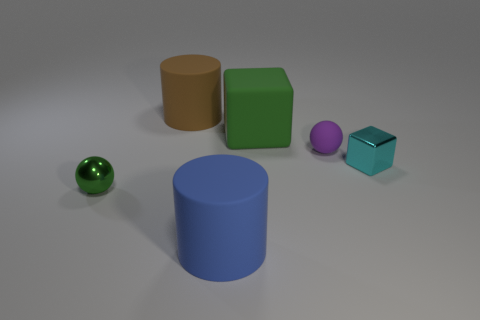There is a small object that is the same color as the big cube; what is its shape?
Make the answer very short. Sphere. What size is the blue thing?
Your response must be concise. Large. How many brown cylinders have the same size as the green rubber block?
Your response must be concise. 1. There is a metal object right of the big green matte cube; is it the same size as the cube left of the purple ball?
Your answer should be compact. No. There is a metallic thing behind the tiny metal sphere; what shape is it?
Give a very brief answer. Cube. What material is the block that is behind the tiny metal thing that is to the right of the tiny rubber thing?
Ensure brevity in your answer.  Rubber. Are there any tiny matte objects that have the same color as the small rubber sphere?
Make the answer very short. No. There is a cyan cube; does it have the same size as the cylinder that is behind the blue rubber cylinder?
Your answer should be very brief. No. There is a large cylinder that is in front of the metal object that is left of the small cube; how many tiny matte things are to the left of it?
Provide a succinct answer. 0. What number of big blue rubber things are on the right side of the blue cylinder?
Your response must be concise. 0. 